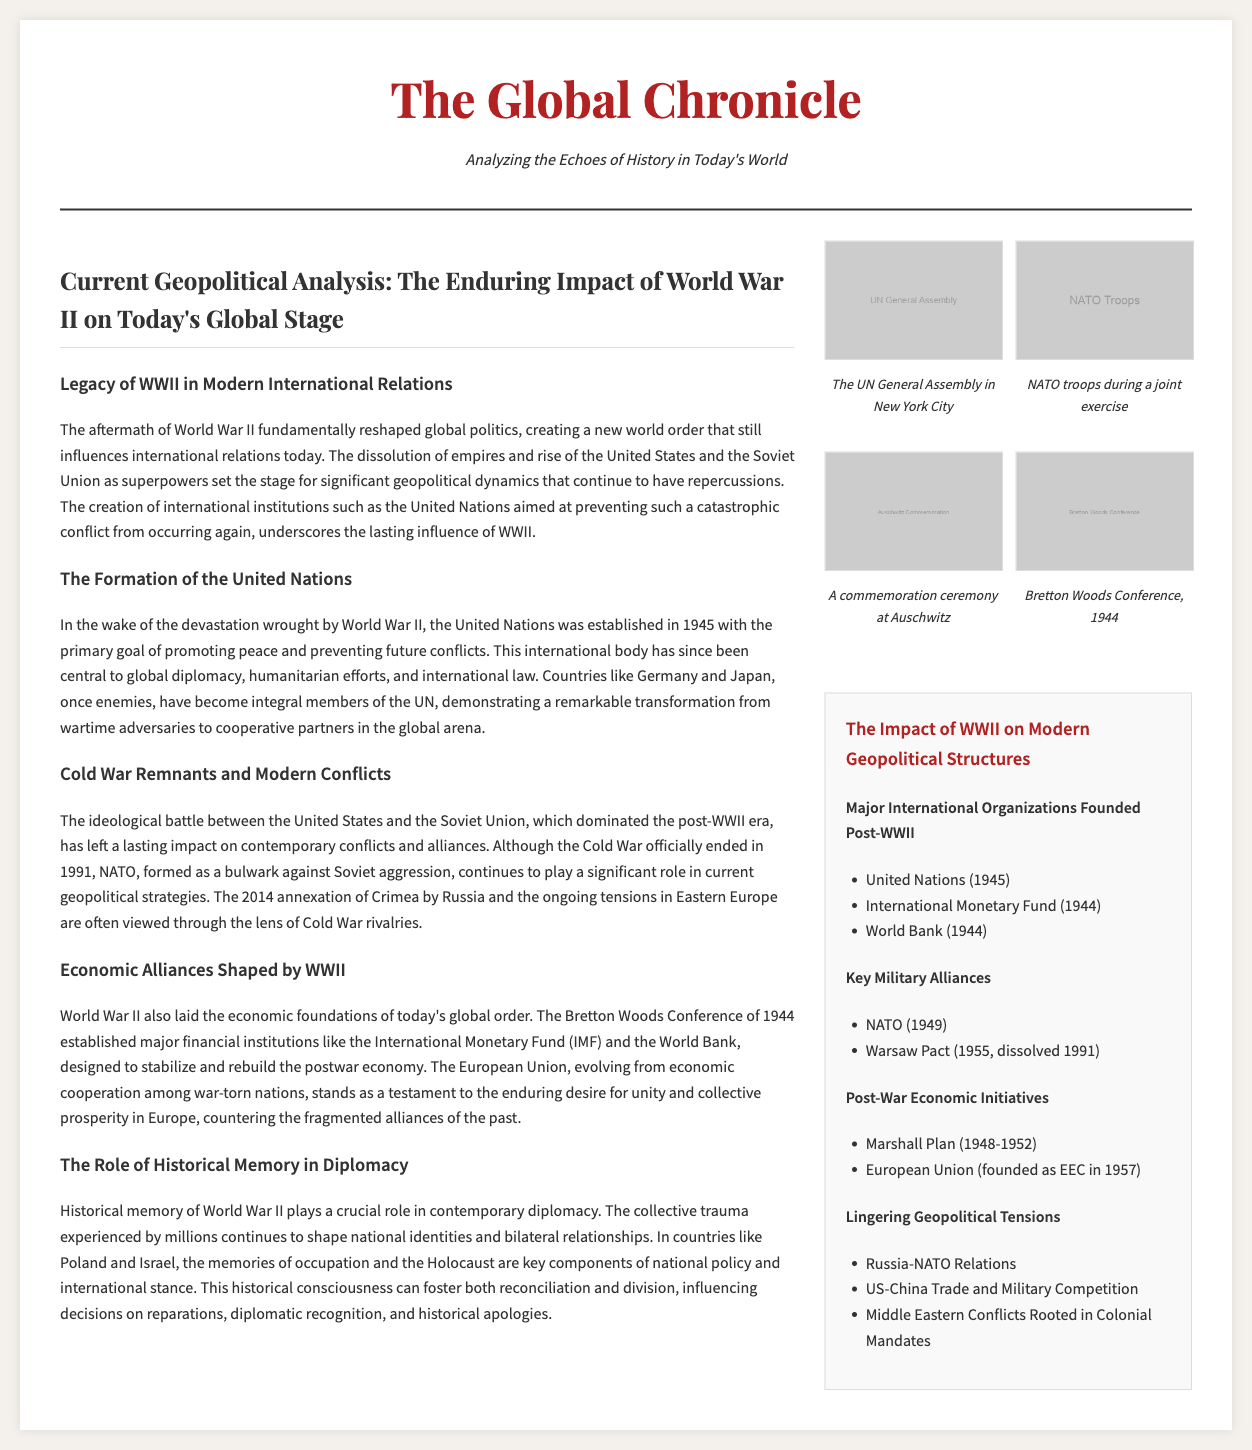What year was the United Nations established? The document states that the United Nations was established in 1945.
Answer: 1945 What major financial institutions were established during the Bretton Woods Conference? The document lists the International Monetary Fund and the World Bank as major institutions founded during this conference in 1944.
Answer: International Monetary Fund and World Bank What is the main role of the United Nations? The document indicates that the United Nations was created to promote peace and prevent future conflicts.
Answer: Promote peace and prevent future conflicts Which two countries transformed from enemies to integral UN members? The document highlights Germany and Japan as countries that underwent such transformation.
Answer: Germany and Japan What conflict is associated with lingering geopolitical tensions mentioned in the infographic? The document notes that Russia-NATO Relations are one of the lingering geopolitical tensions.
Answer: Russia-NATO Relations Why was NATO formed according to the article? The article states that NATO was formed as a bulwark against Soviet aggression.
Answer: Against Soviet aggression What historical event significantly shapes national identities in countries like Poland? The document mentions the memories of occupation and the Holocaust shaping national identities in countries like Poland.
Answer: The Holocaust How does historical memory influence diplomacy today? The document explains that historical memory can foster both reconciliation and division in contemporary diplomacy.
Answer: Reconciliation and division 